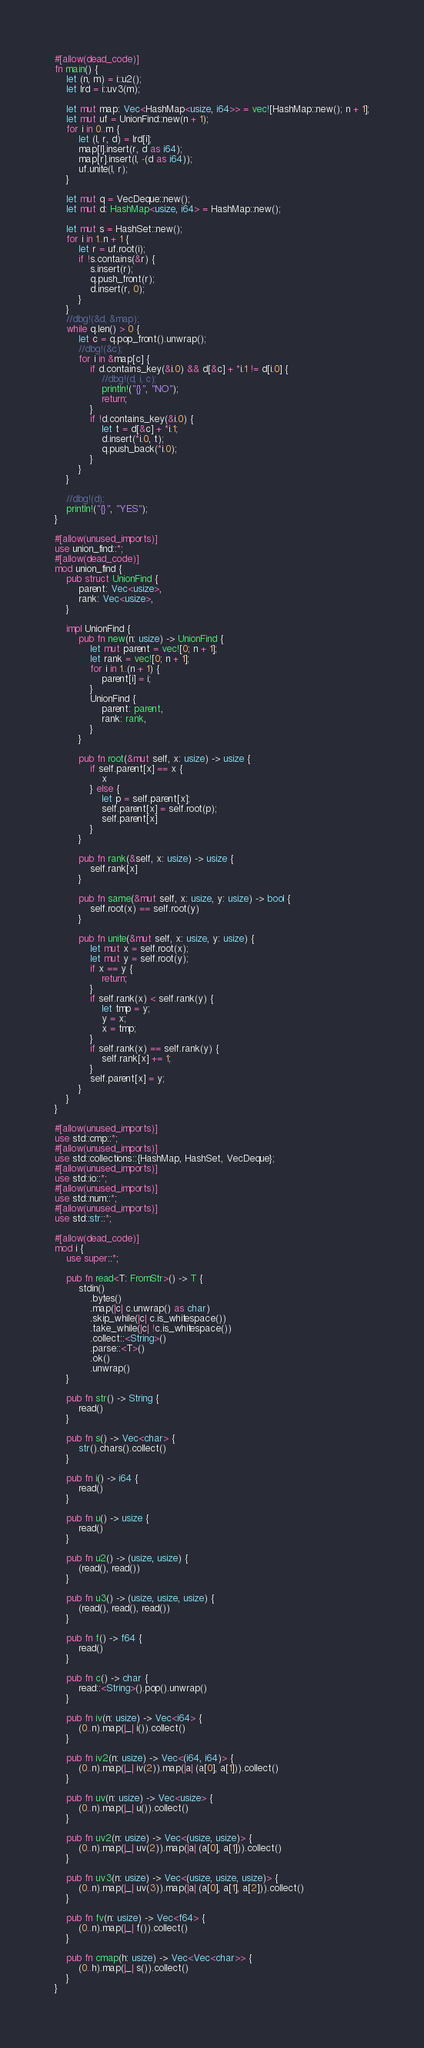<code> <loc_0><loc_0><loc_500><loc_500><_Rust_>#[allow(dead_code)]
fn main() {
    let (n, m) = i::u2();
    let lrd = i::uv3(m);

    let mut map: Vec<HashMap<usize, i64>> = vec![HashMap::new(); n + 1];
    let mut uf = UnionFind::new(n + 1);
    for i in 0..m {
        let (l, r, d) = lrd[i];
        map[l].insert(r, d as i64);
        map[r].insert(l, -(d as i64));
        uf.unite(l, r);
    }

    let mut q = VecDeque::new();
    let mut d: HashMap<usize, i64> = HashMap::new();

    let mut s = HashSet::new();
    for i in 1..n + 1 {
        let r = uf.root(i);
        if !s.contains(&r) {
            s.insert(r);
            q.push_front(r);
            d.insert(r, 0);
        }
    }
    //dbg!(&d, &map);
    while q.len() > 0 {
        let c = q.pop_front().unwrap();
        //dbg!(&c);
        for i in &map[c] {
            if d.contains_key(&i.0) && d[&c] + *i.1 != d[i.0] {
                //dbg!(d, i, c);
                println!("{}", "NO");
                return;
            }
            if !d.contains_key(&i.0) {
                let t = d[&c] + *i.1;
                d.insert(*i.0, t);
                q.push_back(*i.0);
            }
        }
    }

    //dbg!(d);
    println!("{}", "YES");
}

#[allow(unused_imports)]
use union_find::*;
#[allow(dead_code)]
mod union_find {
    pub struct UnionFind {
        parent: Vec<usize>,
        rank: Vec<usize>,
    }

    impl UnionFind {
        pub fn new(n: usize) -> UnionFind {
            let mut parent = vec![0; n + 1];
            let rank = vec![0; n + 1];
            for i in 1..(n + 1) {
                parent[i] = i;
            }
            UnionFind {
                parent: parent,
                rank: rank,
            }
        }

        pub fn root(&mut self, x: usize) -> usize {
            if self.parent[x] == x {
                x
            } else {
                let p = self.parent[x];
                self.parent[x] = self.root(p);
                self.parent[x]
            }
        }

        pub fn rank(&self, x: usize) -> usize {
            self.rank[x]
        }

        pub fn same(&mut self, x: usize, y: usize) -> bool {
            self.root(x) == self.root(y)
        }

        pub fn unite(&mut self, x: usize, y: usize) {
            let mut x = self.root(x);
            let mut y = self.root(y);
            if x == y {
                return;
            }
            if self.rank(x) < self.rank(y) {
                let tmp = y;
                y = x;
                x = tmp;
            }
            if self.rank(x) == self.rank(y) {
                self.rank[x] += 1;
            }
            self.parent[x] = y;
        }
    }
}

#[allow(unused_imports)]
use std::cmp::*;
#[allow(unused_imports)]
use std::collections::{HashMap, HashSet, VecDeque};
#[allow(unused_imports)]
use std::io::*;
#[allow(unused_imports)]
use std::num::*;
#[allow(unused_imports)]
use std::str::*;

#[allow(dead_code)]
mod i {
    use super::*;

    pub fn read<T: FromStr>() -> T {
        stdin()
            .bytes()
            .map(|c| c.unwrap() as char)
            .skip_while(|c| c.is_whitespace())
            .take_while(|c| !c.is_whitespace())
            .collect::<String>()
            .parse::<T>()
            .ok()
            .unwrap()
    }

    pub fn str() -> String {
        read()
    }

    pub fn s() -> Vec<char> {
        str().chars().collect()
    }

    pub fn i() -> i64 {
        read()
    }

    pub fn u() -> usize {
        read()
    }

    pub fn u2() -> (usize, usize) {
        (read(), read())
    }

    pub fn u3() -> (usize, usize, usize) {
        (read(), read(), read())
    }

    pub fn f() -> f64 {
        read()
    }

    pub fn c() -> char {
        read::<String>().pop().unwrap()
    }

    pub fn iv(n: usize) -> Vec<i64> {
        (0..n).map(|_| i()).collect()
    }

    pub fn iv2(n: usize) -> Vec<(i64, i64)> {
        (0..n).map(|_| iv(2)).map(|a| (a[0], a[1])).collect()
    }

    pub fn uv(n: usize) -> Vec<usize> {
        (0..n).map(|_| u()).collect()
    }

    pub fn uv2(n: usize) -> Vec<(usize, usize)> {
        (0..n).map(|_| uv(2)).map(|a| (a[0], a[1])).collect()
    }

    pub fn uv3(n: usize) -> Vec<(usize, usize, usize)> {
        (0..n).map(|_| uv(3)).map(|a| (a[0], a[1], a[2])).collect()
    }

    pub fn fv(n: usize) -> Vec<f64> {
        (0..n).map(|_| f()).collect()
    }

    pub fn cmap(h: usize) -> Vec<Vec<char>> {
        (0..h).map(|_| s()).collect()
    }
}
</code> 